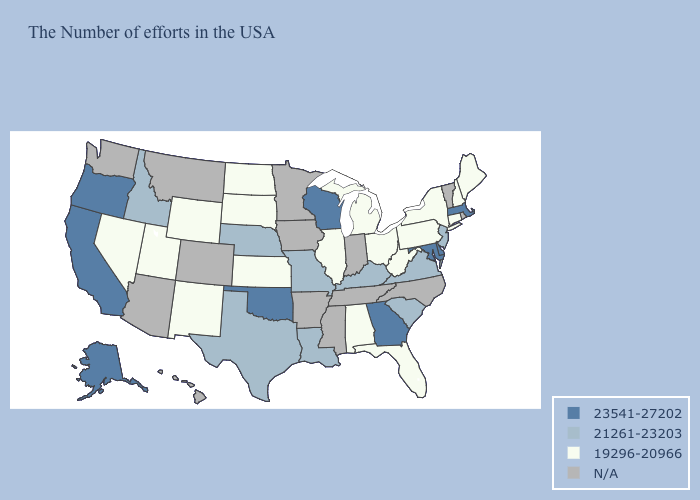Does the map have missing data?
Give a very brief answer. Yes. What is the highest value in states that border Montana?
Keep it brief. 21261-23203. What is the lowest value in the MidWest?
Quick response, please. 19296-20966. Does the map have missing data?
Answer briefly. Yes. What is the highest value in states that border Virginia?
Write a very short answer. 23541-27202. Is the legend a continuous bar?
Quick response, please. No. Among the states that border Tennessee , which have the lowest value?
Concise answer only. Alabama. What is the value of North Dakota?
Answer briefly. 19296-20966. Which states have the lowest value in the MidWest?
Give a very brief answer. Ohio, Michigan, Illinois, Kansas, South Dakota, North Dakota. Does South Carolina have the lowest value in the USA?
Quick response, please. No. Which states have the lowest value in the USA?
Give a very brief answer. Maine, New Hampshire, Connecticut, New York, Pennsylvania, West Virginia, Ohio, Florida, Michigan, Alabama, Illinois, Kansas, South Dakota, North Dakota, Wyoming, New Mexico, Utah, Nevada. Which states have the lowest value in the West?
Answer briefly. Wyoming, New Mexico, Utah, Nevada. What is the value of Vermont?
Quick response, please. N/A. Does the map have missing data?
Be succinct. Yes. Which states have the lowest value in the West?
Concise answer only. Wyoming, New Mexico, Utah, Nevada. 